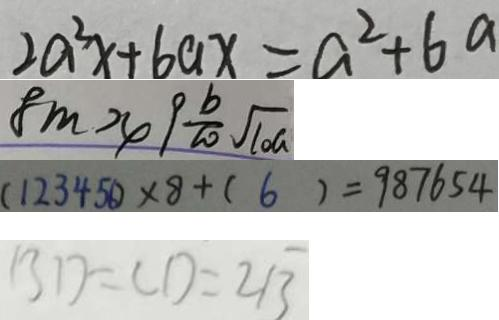Convert formula to latex. <formula><loc_0><loc_0><loc_500><loc_500>2 a ^ { 2 } x + 6 a x = a ^ { 2 } + 6 a 
 8 m > 4 9 \frac { b } { 2 0 } \sqrt { 1 0 a } 
 ( 1 2 3 4 5 6 ) \times 8 + ( 6 ) = 9 8 7 6 5 4 
 B D = C D = 2 \sqrt { 3 }</formula> 